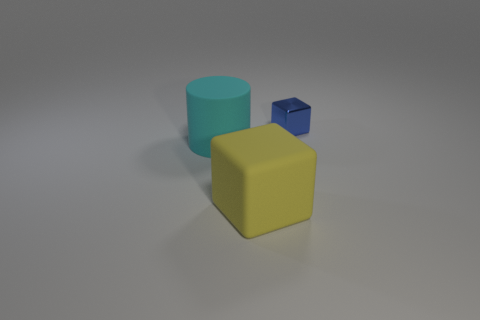What is the color of the object on the left side of the block on the left side of the small metallic object?
Give a very brief answer. Cyan. Is there any other thing that is the same shape as the shiny object?
Provide a short and direct response. Yes. Are there an equal number of yellow matte objects right of the small object and yellow rubber objects on the left side of the large block?
Provide a succinct answer. Yes. How many spheres are big cyan rubber objects or big things?
Provide a short and direct response. 0. What number of other objects are there of the same material as the small blue cube?
Provide a succinct answer. 0. There is a large rubber thing on the right side of the big cylinder; what is its shape?
Offer a terse response. Cube. The object that is in front of the thing to the left of the yellow cube is made of what material?
Give a very brief answer. Rubber. Is the number of cyan objects behind the large cyan rubber cylinder greater than the number of small gray cylinders?
Offer a very short reply. No. What is the shape of the other rubber object that is the same size as the yellow object?
Your response must be concise. Cylinder. There is a object right of the block in front of the blue cube; what number of large cylinders are to the right of it?
Make the answer very short. 0. 